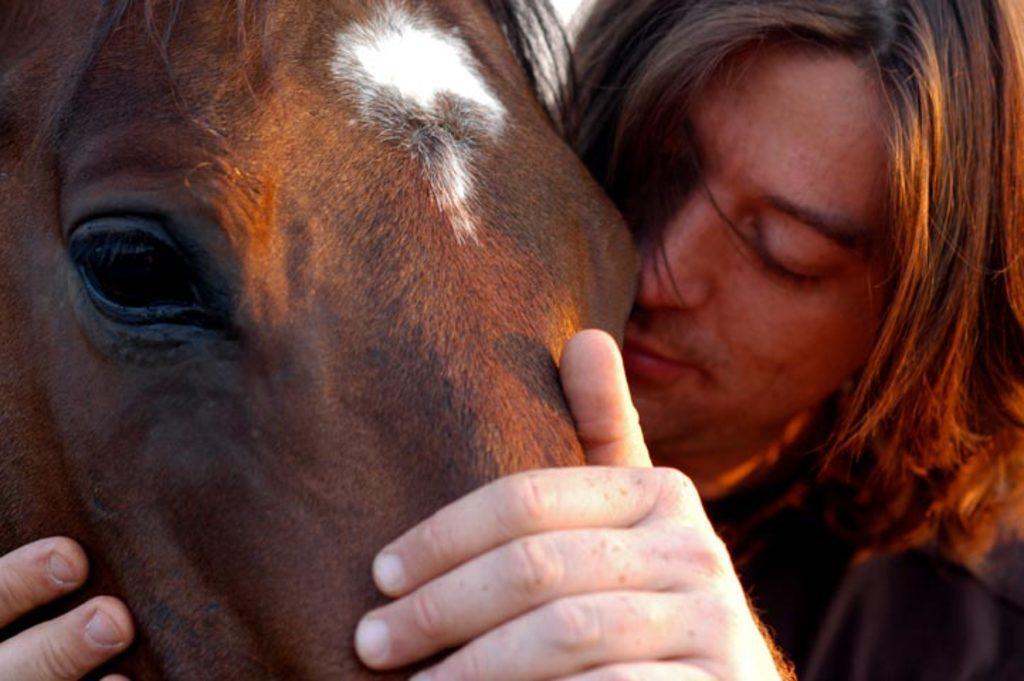Please provide a concise description of this image. In this picture there is a horse and a man. The horse is having a white mark on its head. The man is holding the horse. 